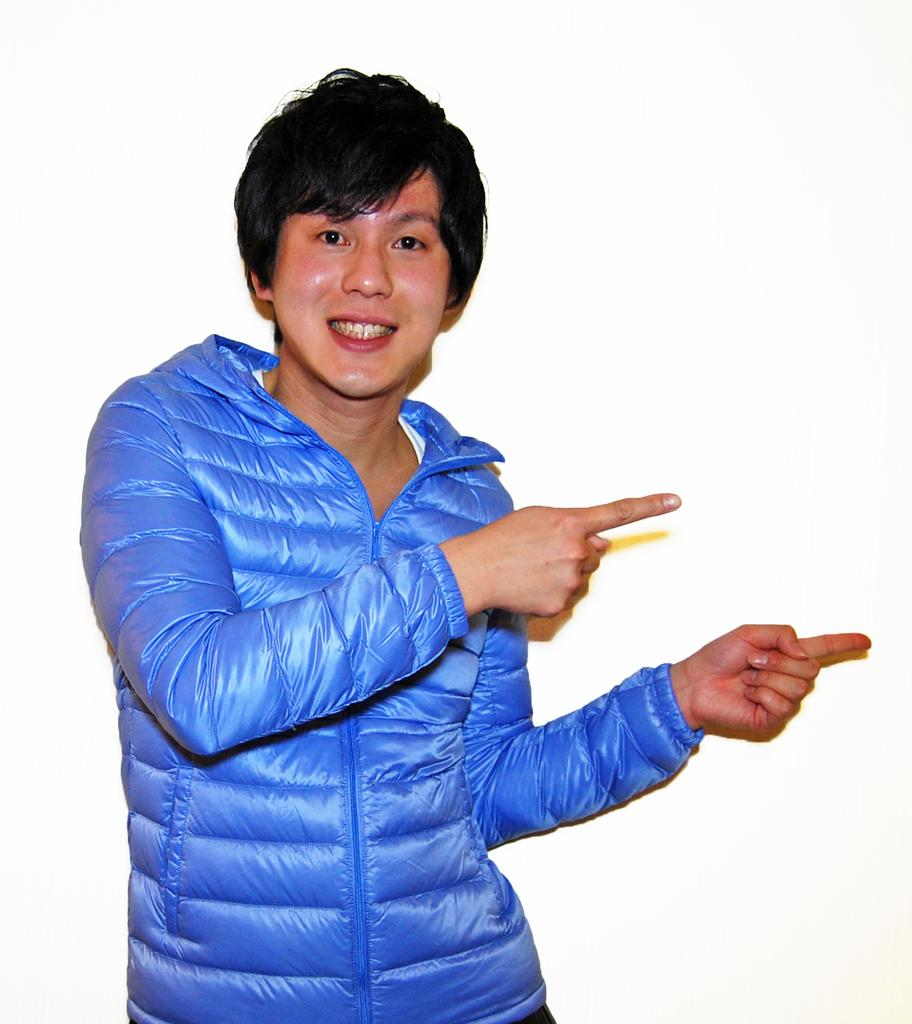Who or what is the main subject of the image? There is a person in the image. What can be seen in the background of the image? The background of the image is white. What type of gun is hidden in the bushes in the image? There are no bushes or guns present in the image; it only features a person with a white background. 